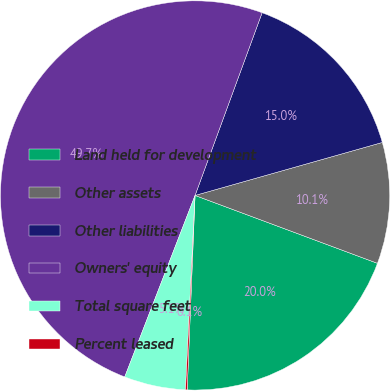<chart> <loc_0><loc_0><loc_500><loc_500><pie_chart><fcel>Land held for development<fcel>Other assets<fcel>Other liabilities<fcel>Owners' equity<fcel>Total square feet<fcel>Percent leased<nl><fcel>19.97%<fcel>10.06%<fcel>15.01%<fcel>49.71%<fcel>5.1%<fcel>0.14%<nl></chart> 